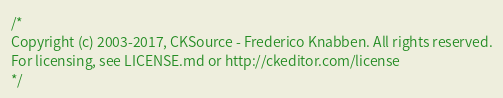<code> <loc_0><loc_0><loc_500><loc_500><_CSS_>/*
Copyright (c) 2003-2017, CKSource - Frederico Knabben. All rights reserved.
For licensing, see LICENSE.md or http://ckeditor.com/license
*/</code> 